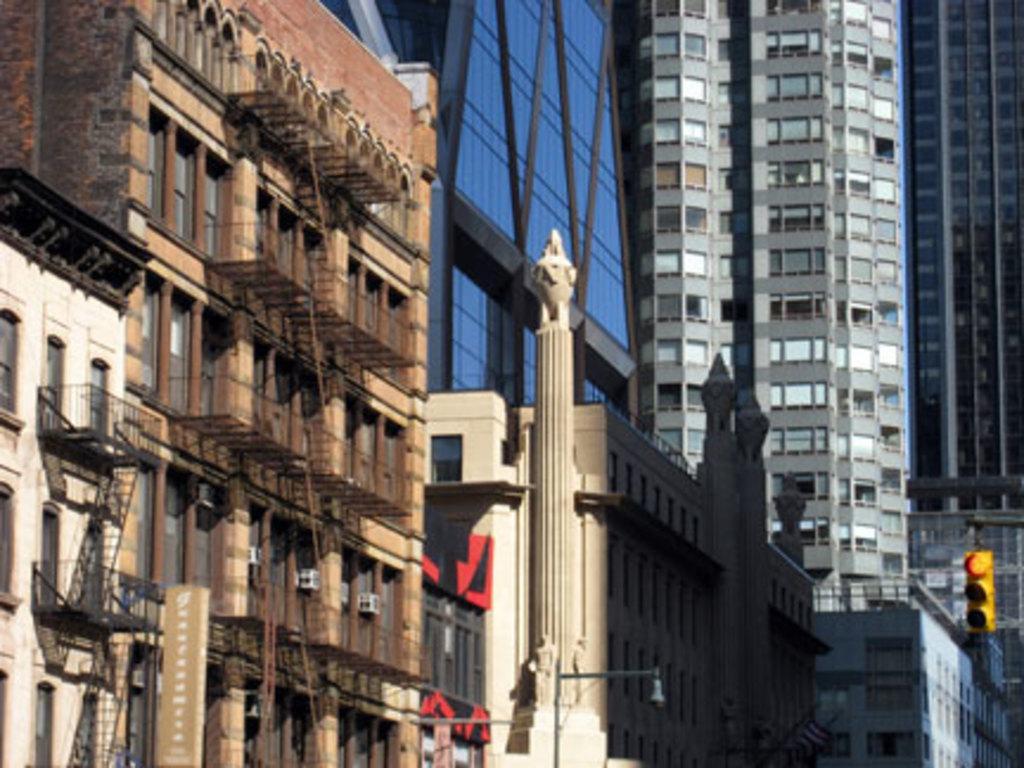Describe this image in one or two sentences. This image consists of buildings and skyscrapers along with windows. In the middle, there is a pillar. 